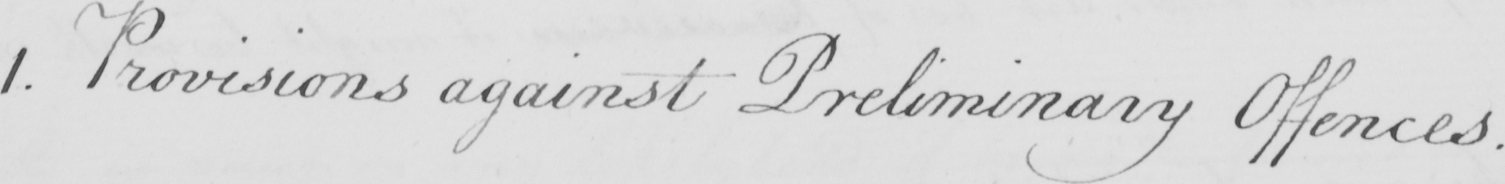What text is written in this handwritten line? 1 . Provisions against Preliminary Offences . 